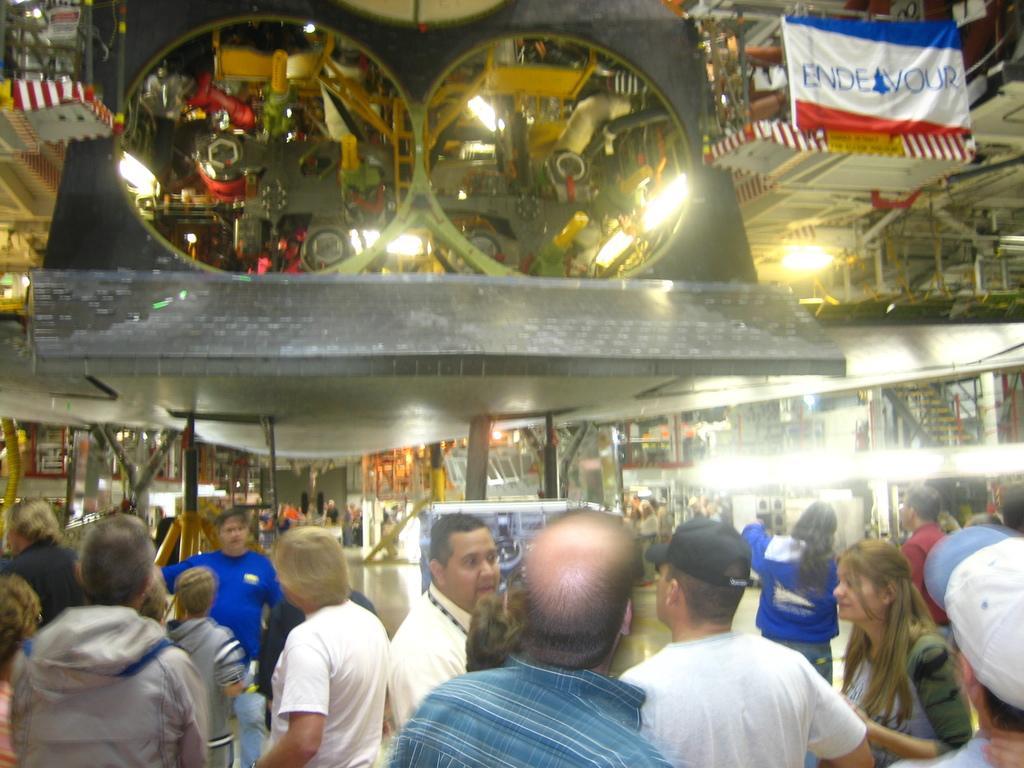In one or two sentences, can you explain what this image depicts? There are groups of people standing. These look like the mirrors. This looks like a banner, which is hanging. I think these are the pillars. I can see the reflection of the machines and few objects in the mirror. 